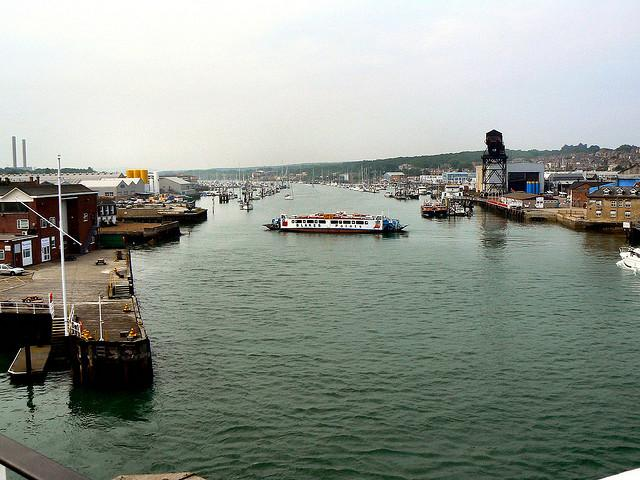What color are the end bridges for the boat suspended in the middle of the river? blue 